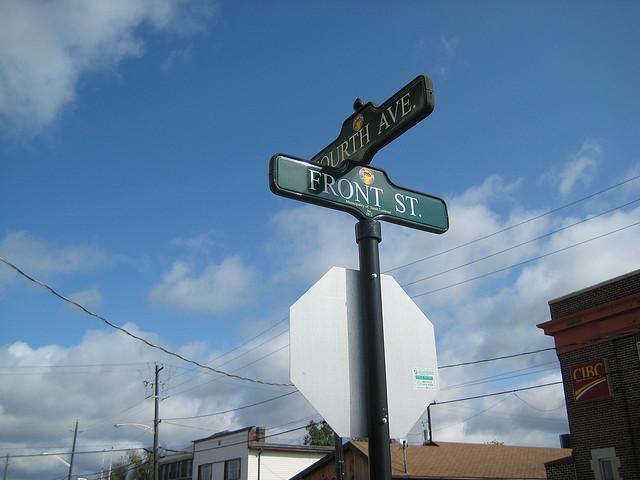How many signs are on the pole?
Give a very brief answer. 3. How many white chairs in the background?
Give a very brief answer. 0. 